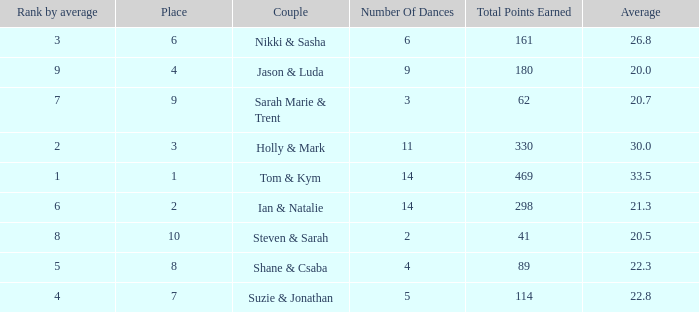What is the number of dances total number if the average is 22.3? 1.0. 